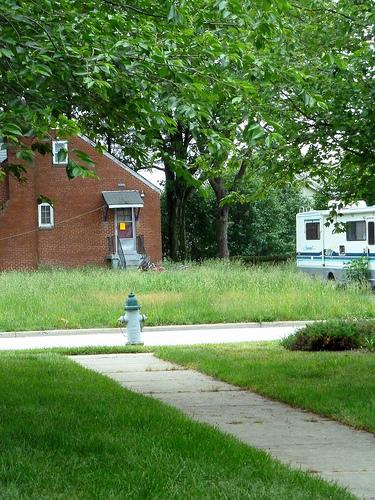How do the leaves of the tree in the image appear? The leaves of the tree are green and seem healthy. Describe the appearance of the bush beside the street. The bush beside the street is low lying with green and brown leaves. Can you count the number of windows on the red brick building? There are at least 2 windows on the red brick building. What is the dominant color of the fire hydrant in the image? The dominant color of the fire hydrant is a mix of green, blue, and white. What odd item is found in the tall grass? A red motorcycle is found in the tall grass. Identify the state of the sidewalk in the image. The sidewalk has patches of grass and weeds growing on it. What kind of vehicle is parked outside the building and what is its most distinctive feature? An RV is parked outside the building, and its most distinctive feature is its white color with blue lines on it. Give a brief description of the red brick building's exterior features. The red brick building has a door with a yellow note on it, white windows, and a cover over the door. What do you notice about the RV parked in the grass? The RV is white with blue lines on it, has windows, and a metal ladder. What does the note on the door look like and what is its color? The note on the door appears to be a small yellow piece of paper. In the available options, which is the most likely accurate representation of the fire hydrant: green, blue, or white and green? B. Blue Is there any building with windows made of white and with a road nearby? Yes, red brick 2 story building Provide a brief description of the exterior of the motorhome. White motor home with blue lines and a metal ladder Describe any trees that are present in the image next to the building. Trees with green leaves beside the building Which object is next to the road, red or blue fire hydrant? Red fire hydrant Can you identify any objects that are blue in color in the image? Blue fire hydrant and blue lines on the motor home Are there any purple flowers growing in the yard? There are no mentions of purple flowers or any flowers at all. There's only green grass, patches of grass, a low lying green bush, and a small shrub mentioned. Is there a bicycle lying on the sidewalk? No, it's not mentioned in the image. Analyze the diagram and describe the arrangement of the building, sidewalk, and road. Red brick building facing the narrow road with a sidewalk leading to the road Create a short narrative based on the image's contents, including a description of the encompassed elements. A quiet day in front of a red brick building, with a white and blue RV parked nearby, and a green fire hydrant rests by the road. Weeds grow on the sidewalk. What kind of light fixture can be seen on the brick wall? Porch light Which color combinations can be found on the parked RV? White and blue Is there any unusual vegetation growing on or around any vehicles in the image? Leaves growing on the RV Identify any text on the door and provide a brief description of the note's color and shape. Yellow piece of paper Based on the image, what activity is happening around the red brick building? No activity observed Explain whether there is a well-maintained sidewalk or any vegetation overgrowth. Sidewalk with weeds growing Describe the fire hydrant's appearance and location in relation to the road. Green and grey fire hydrant next to the road List three objects visible in the yard area. Tall grass, small shrub, green grass What type of building is located near the sidewalk and road? Red brick 2 story building 